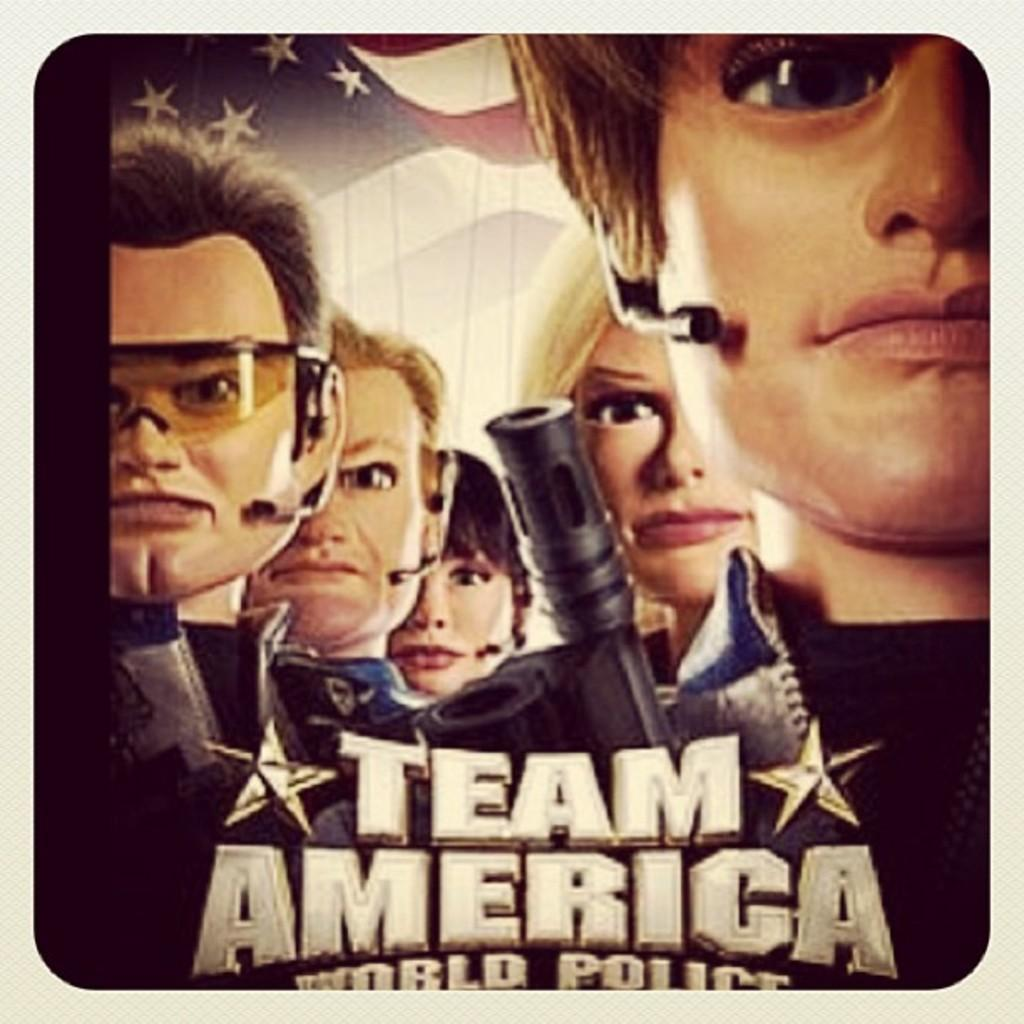What is written or displayed at the bottom of the image? There is text at the bottom of the image. What type of characters can be seen in the middle of the image? There are animated humans in the middle of the image. What can be seen in the background of the image? There is a flag in the background of the image. How many ducks are present on the side of the animated humans in the image? There are no ducks present in the image. Who is the friend of the animated humans in the image? The provided facts do not mention any friends of the animated humans in the image. 